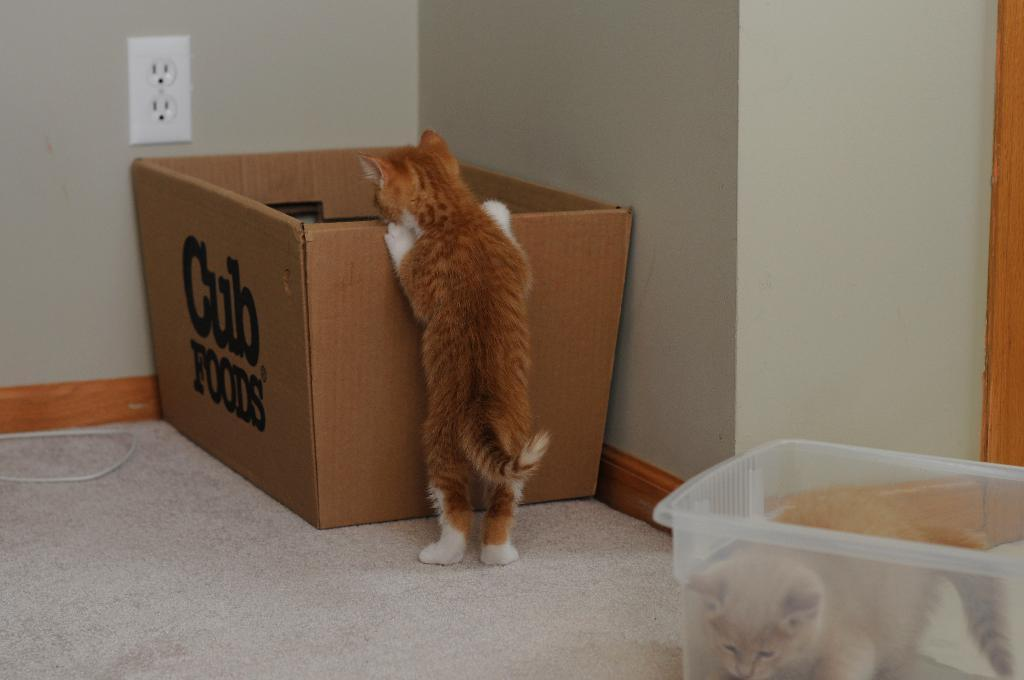<image>
Render a clear and concise summary of the photo. Cat that is trying to look into a box from Cub Foods. 